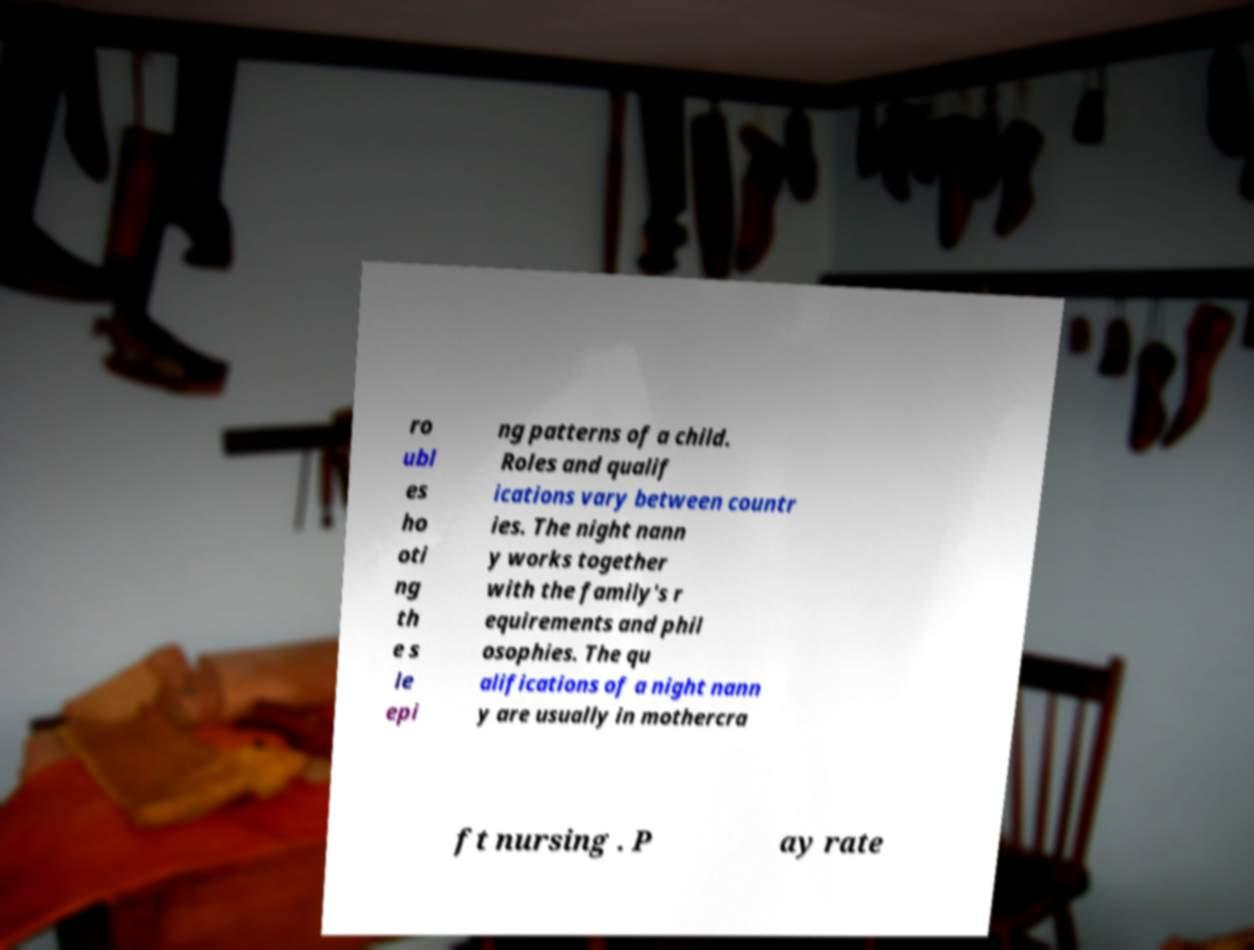Please identify and transcribe the text found in this image. ro ubl es ho oti ng th e s le epi ng patterns of a child. Roles and qualif ications vary between countr ies. The night nann y works together with the family's r equirements and phil osophies. The qu alifications of a night nann y are usually in mothercra ft nursing . P ay rate 